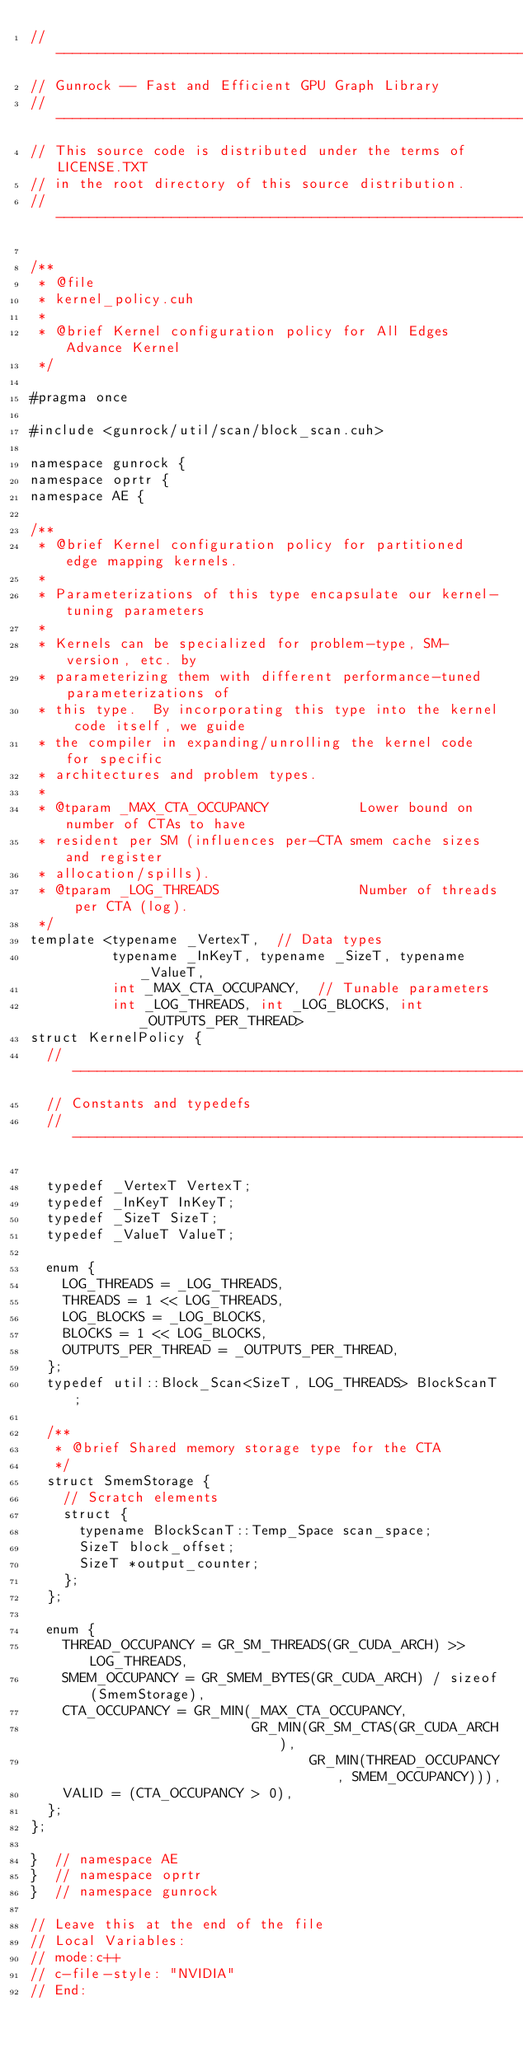<code> <loc_0><loc_0><loc_500><loc_500><_Cuda_>// ----------------------------------------------------------------
// Gunrock -- Fast and Efficient GPU Graph Library
// ----------------------------------------------------------------
// This source code is distributed under the terms of LICENSE.TXT
// in the root directory of this source distribution.
// ----------------------------------------------------------------

/**
 * @file
 * kernel_policy.cuh
 *
 * @brief Kernel configuration policy for All Edges Advance Kernel
 */

#pragma once

#include <gunrock/util/scan/block_scan.cuh>

namespace gunrock {
namespace oprtr {
namespace AE {

/**
 * @brief Kernel configuration policy for partitioned edge mapping kernels.
 *
 * Parameterizations of this type encapsulate our kernel-tuning parameters
 *
 * Kernels can be specialized for problem-type, SM-version, etc. by
 * parameterizing them with different performance-tuned parameterizations of
 * this type.  By incorporating this type into the kernel code itself, we guide
 * the compiler in expanding/unrolling the kernel code for specific
 * architectures and problem types.
 *
 * @tparam _MAX_CTA_OCCUPANCY           Lower bound on number of CTAs to have
 * resident per SM (influences per-CTA smem cache sizes and register
 * allocation/spills).
 * @tparam _LOG_THREADS                 Number of threads per CTA (log).
 */
template <typename _VertexT,  // Data types
          typename _InKeyT, typename _SizeT, typename _ValueT,
          int _MAX_CTA_OCCUPANCY,  // Tunable parameters
          int _LOG_THREADS, int _LOG_BLOCKS, int _OUTPUTS_PER_THREAD>
struct KernelPolicy {
  //---------------------------------------------------------------------
  // Constants and typedefs
  //---------------------------------------------------------------------

  typedef _VertexT VertexT;
  typedef _InKeyT InKeyT;
  typedef _SizeT SizeT;
  typedef _ValueT ValueT;

  enum {
    LOG_THREADS = _LOG_THREADS,
    THREADS = 1 << LOG_THREADS,
    LOG_BLOCKS = _LOG_BLOCKS,
    BLOCKS = 1 << LOG_BLOCKS,
    OUTPUTS_PER_THREAD = _OUTPUTS_PER_THREAD,
  };
  typedef util::Block_Scan<SizeT, LOG_THREADS> BlockScanT;

  /**
   * @brief Shared memory storage type for the CTA
   */
  struct SmemStorage {
    // Scratch elements
    struct {
      typename BlockScanT::Temp_Space scan_space;
      SizeT block_offset;
      SizeT *output_counter;
    };
  };

  enum {
    THREAD_OCCUPANCY = GR_SM_THREADS(GR_CUDA_ARCH) >> LOG_THREADS,
    SMEM_OCCUPANCY = GR_SMEM_BYTES(GR_CUDA_ARCH) / sizeof(SmemStorage),
    CTA_OCCUPANCY = GR_MIN(_MAX_CTA_OCCUPANCY,
                           GR_MIN(GR_SM_CTAS(GR_CUDA_ARCH),
                                  GR_MIN(THREAD_OCCUPANCY, SMEM_OCCUPANCY))),
    VALID = (CTA_OCCUPANCY > 0),
  };
};

}  // namespace AE
}  // namespace oprtr
}  // namespace gunrock

// Leave this at the end of the file
// Local Variables:
// mode:c++
// c-file-style: "NVIDIA"
// End:
</code> 